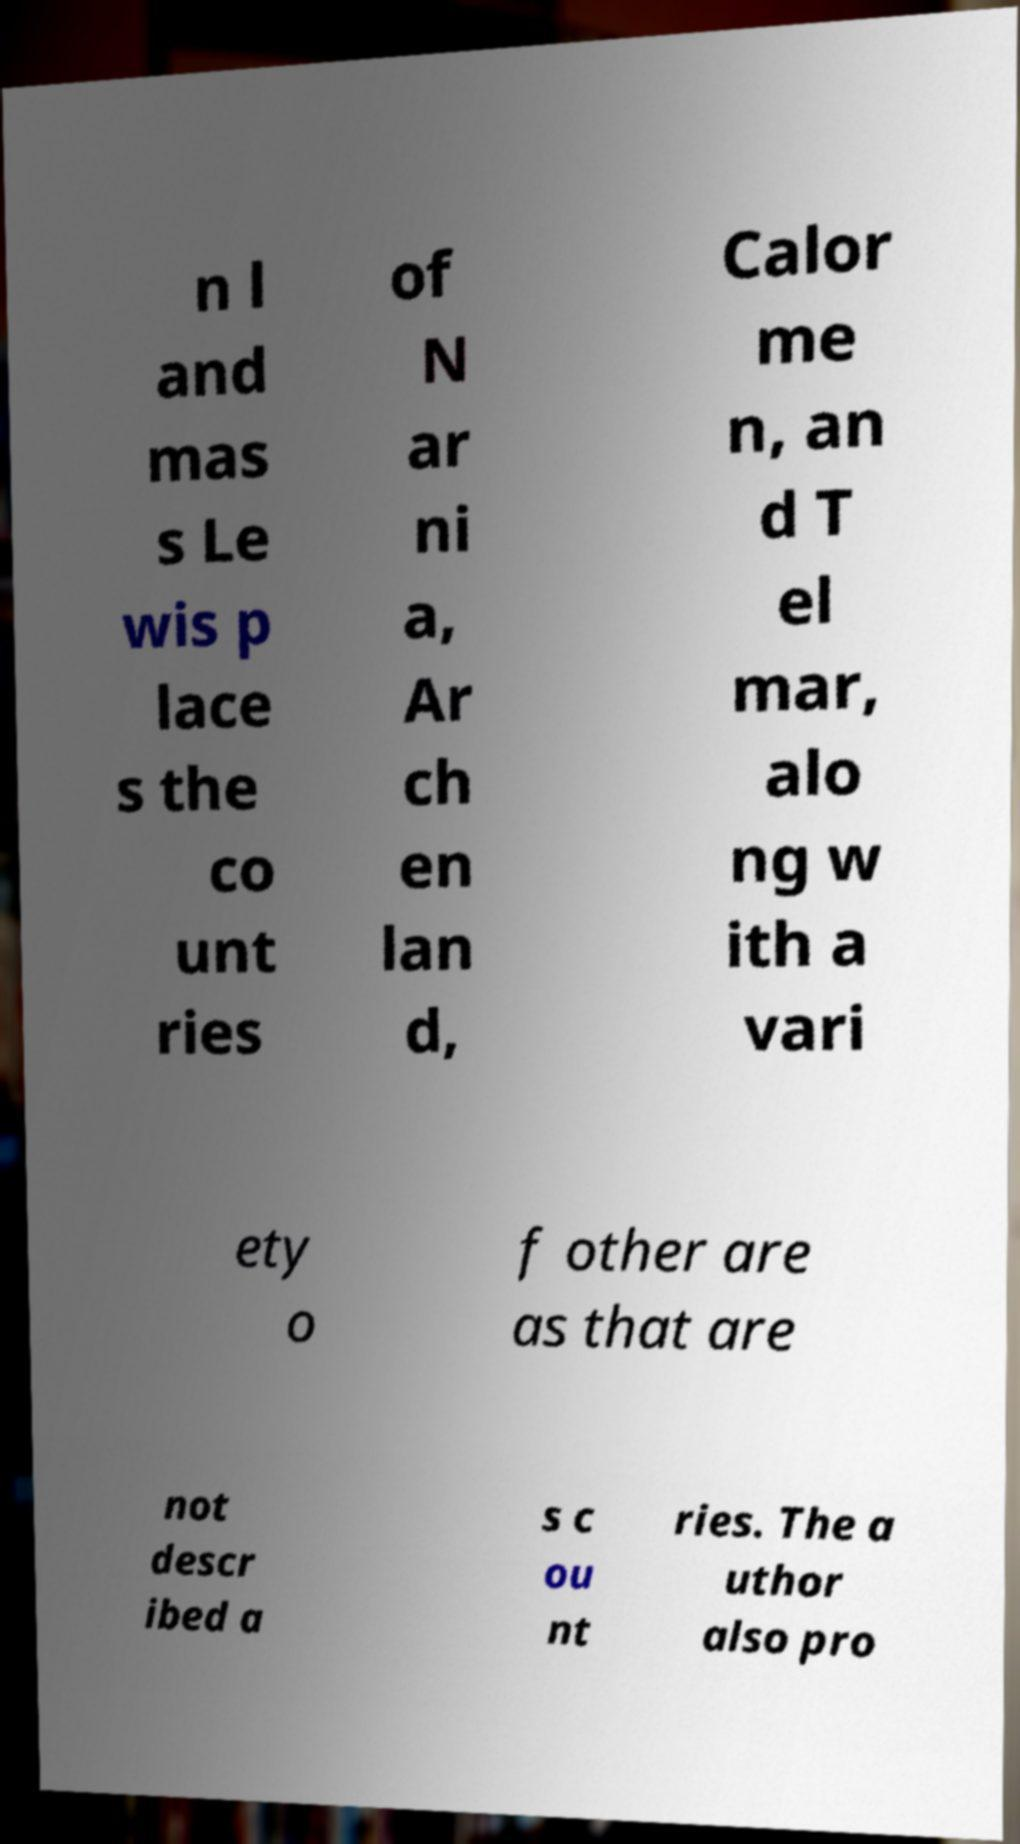Could you extract and type out the text from this image? n l and mas s Le wis p lace s the co unt ries of N ar ni a, Ar ch en lan d, Calor me n, an d T el mar, alo ng w ith a vari ety o f other are as that are not descr ibed a s c ou nt ries. The a uthor also pro 